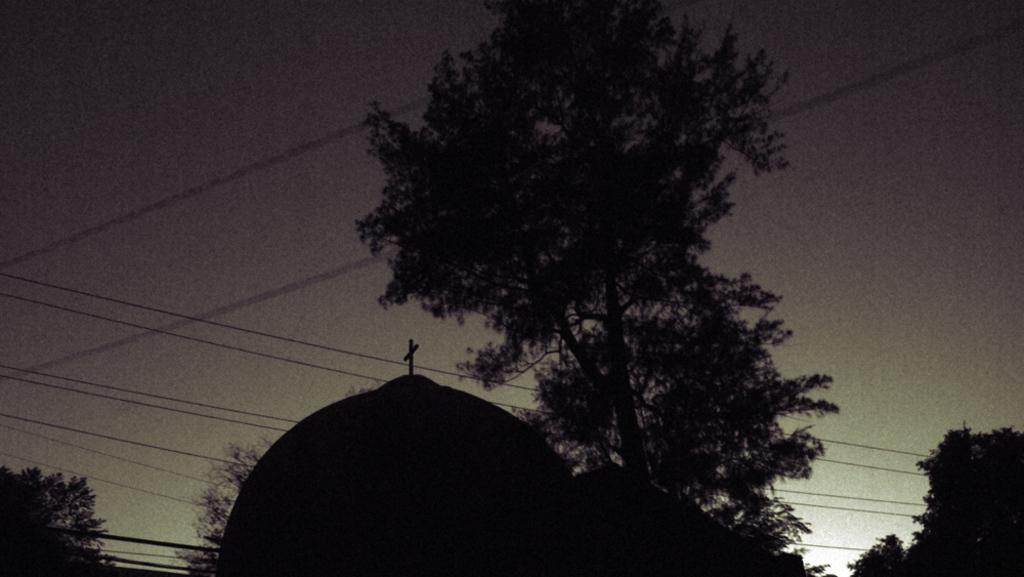What structure is the main focus of the image? There is a dome in the image. What symbol can be seen on the dome? There is a holy cross symbol on the dome. What else is visible behind the dome? There are cables, trees, and the sky visible behind the dome. Can you tell me what day of the week it is in the image? The image does not provide any information about the day of the week. Is there a lake visible in the image? There is no lake present in the image. 